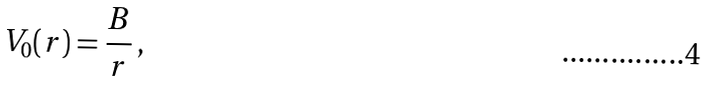Convert formula to latex. <formula><loc_0><loc_0><loc_500><loc_500>V _ { 0 } ( r ) = \frac { B } { r } \, ,</formula> 